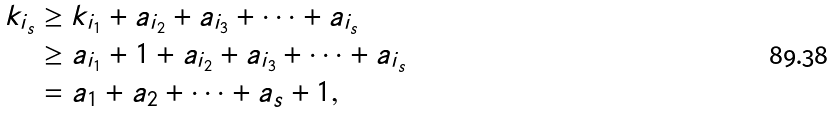Convert formula to latex. <formula><loc_0><loc_0><loc_500><loc_500>k _ { i _ { s } } & \geq k _ { i _ { 1 } } + a _ { i _ { 2 } } + a _ { i _ { 3 } } + \cdots + a _ { i _ { s } } \\ & \geq a _ { i _ { 1 } } + 1 + a _ { i _ { 2 } } + a _ { i _ { 3 } } + \cdots + a _ { i _ { s } } \\ & = a _ { 1 } + a _ { 2 } + \cdots + a _ { s } + 1 ,</formula> 